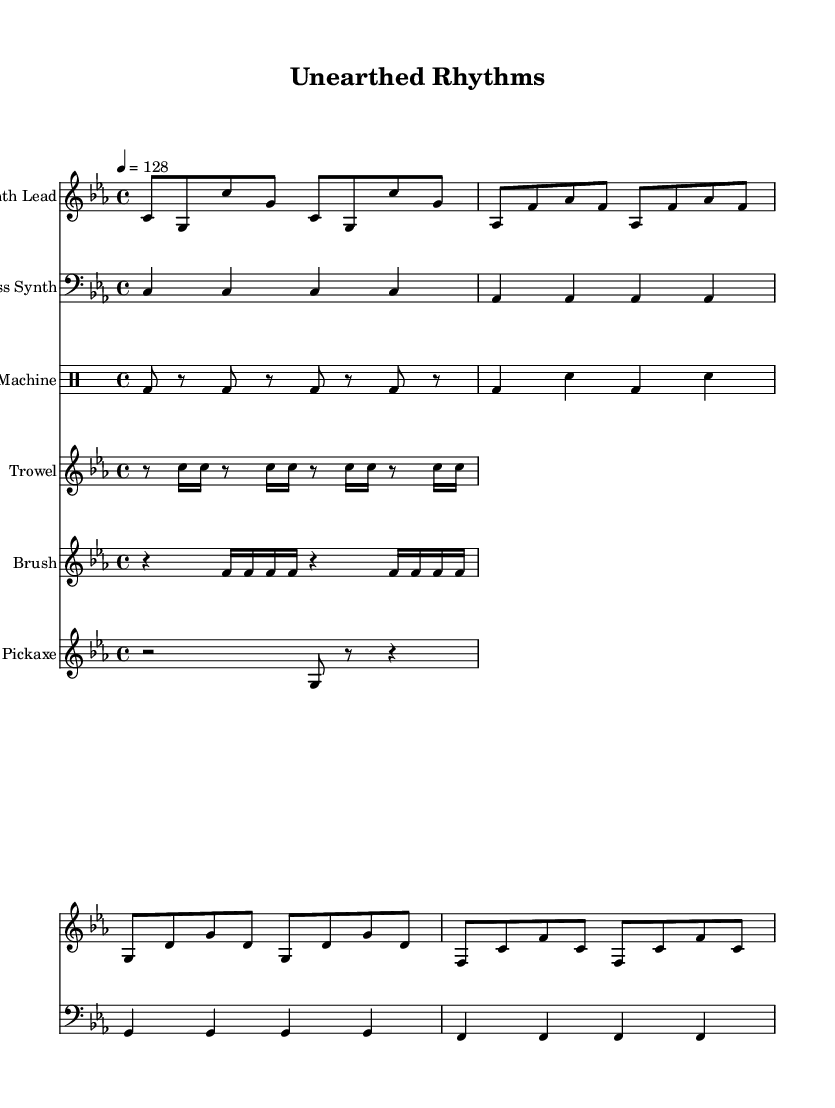What is the key signature of this music? The key signature is set to C minor, which has three flats (B♭, E♭, A♭) indicated at the beginning of the score.
Answer: C minor What is the time signature of this piece? The time signature is noted as 4/4 at the beginning, meaning there are four beats in each measure and a quarter note receives one beat.
Answer: 4/4 What is the tempo marking in this score? The tempo is marked as quarter note equals 128, which indicates the speed at which the music should be played.
Answer: 128 How many different instruments are used in this composition? The score shows a total of five different instrumental parts including synthesizer and percussion sections.
Answer: Five Which instrument has the highest pitch range in this score? The "Synth Lead" part, which is in the treble clef, typically covers a higher pitch range than the others, such as the bass synth and drum machine.
Answer: Synth Lead What sound is being represented by the "Trowel" staff? The "Trowel" staff consists of rhythmic sounds that mimic scraping, as indicated by the repeated pattern of notes and rests.
Answer: Scraping sounds What represents the drum beats in this piece? The "Drum Machine" staff utilizes bass drum and snare patterns as seen in the rhythm pattern provided in that section.
Answer: Drum beats 